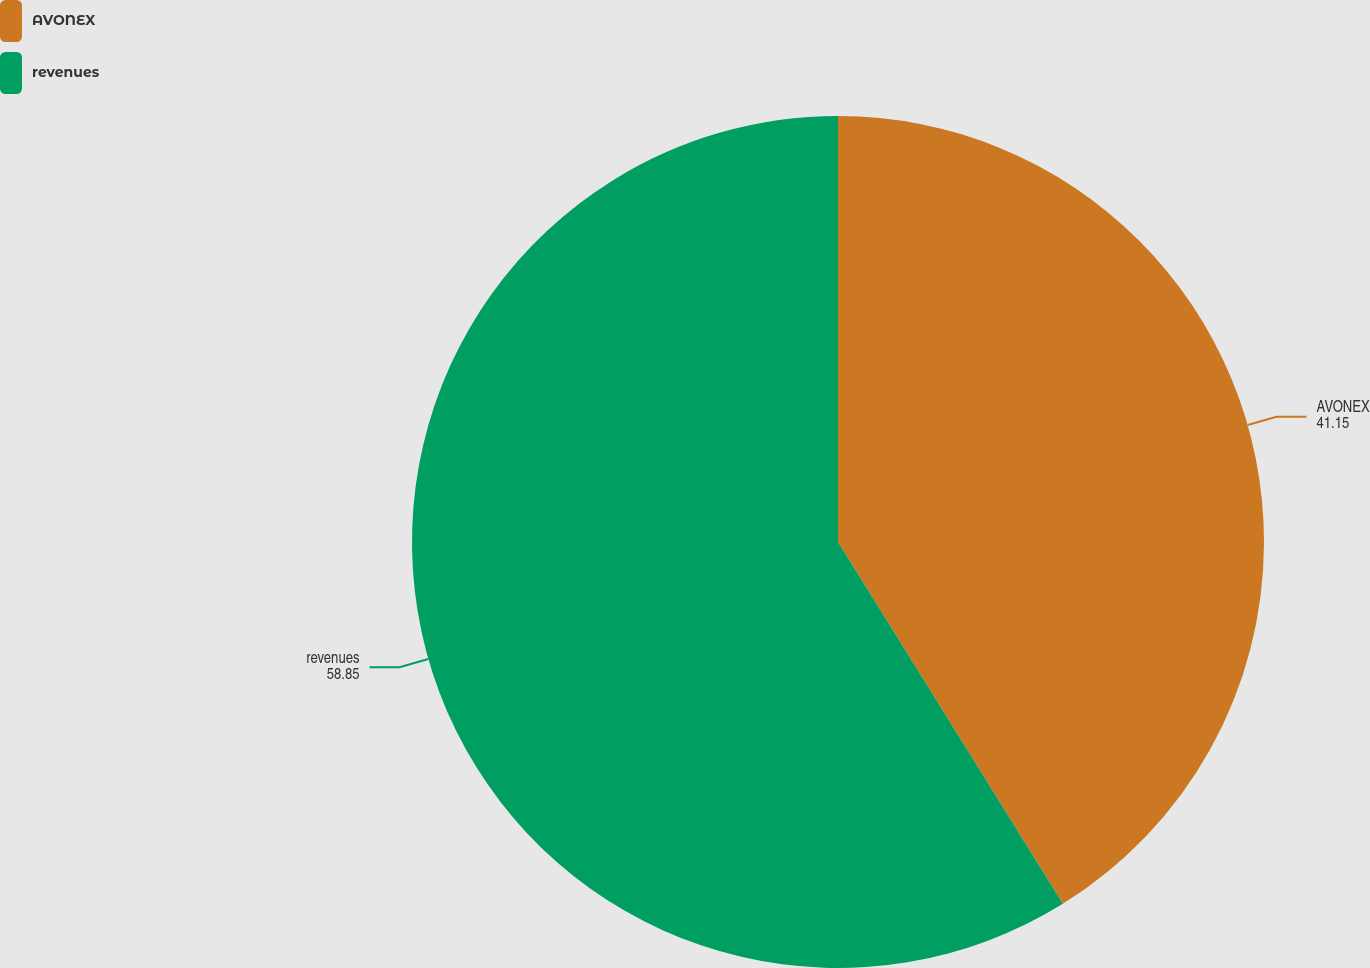Convert chart. <chart><loc_0><loc_0><loc_500><loc_500><pie_chart><fcel>AVONEX<fcel>revenues<nl><fcel>41.15%<fcel>58.85%<nl></chart> 